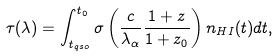<formula> <loc_0><loc_0><loc_500><loc_500>\tau ( \lambda ) = \int ^ { t _ { 0 } } _ { t _ { q s o } } \sigma \left ( \frac { c } { \lambda _ { \alpha } } \frac { 1 + z } { 1 + z _ { 0 } } \right ) n _ { H I } ( t ) d t ,</formula> 